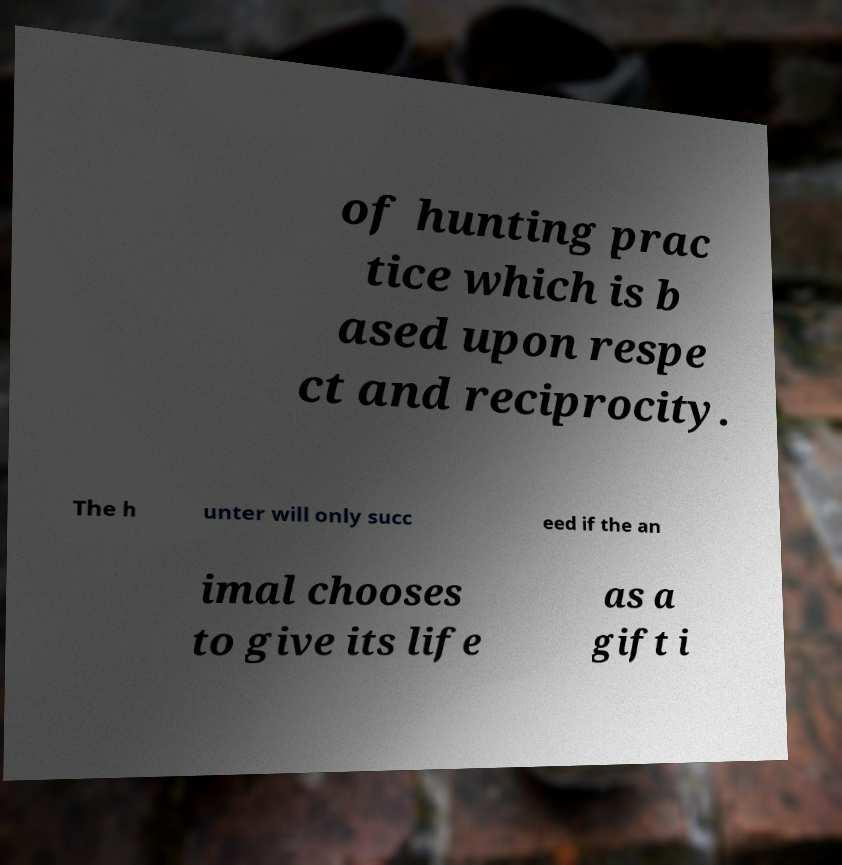Could you assist in decoding the text presented in this image and type it out clearly? of hunting prac tice which is b ased upon respe ct and reciprocity. The h unter will only succ eed if the an imal chooses to give its life as a gift i 